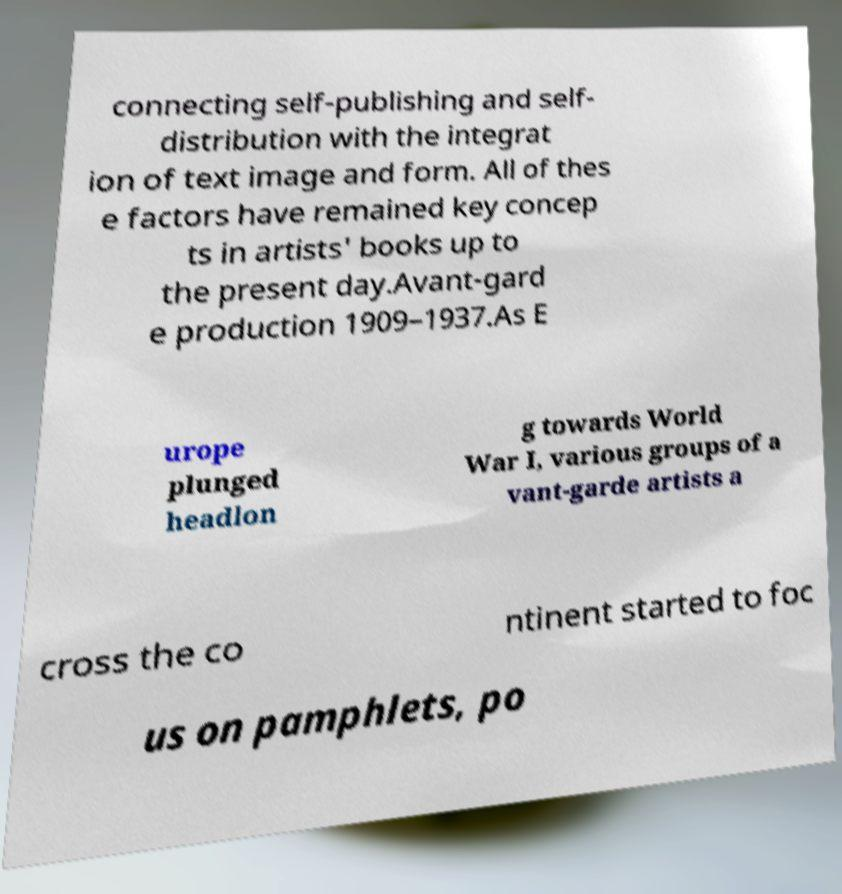Please identify and transcribe the text found in this image. connecting self-publishing and self- distribution with the integrat ion of text image and form. All of thes e factors have remained key concep ts in artists' books up to the present day.Avant-gard e production 1909–1937.As E urope plunged headlon g towards World War I, various groups of a vant-garde artists a cross the co ntinent started to foc us on pamphlets, po 